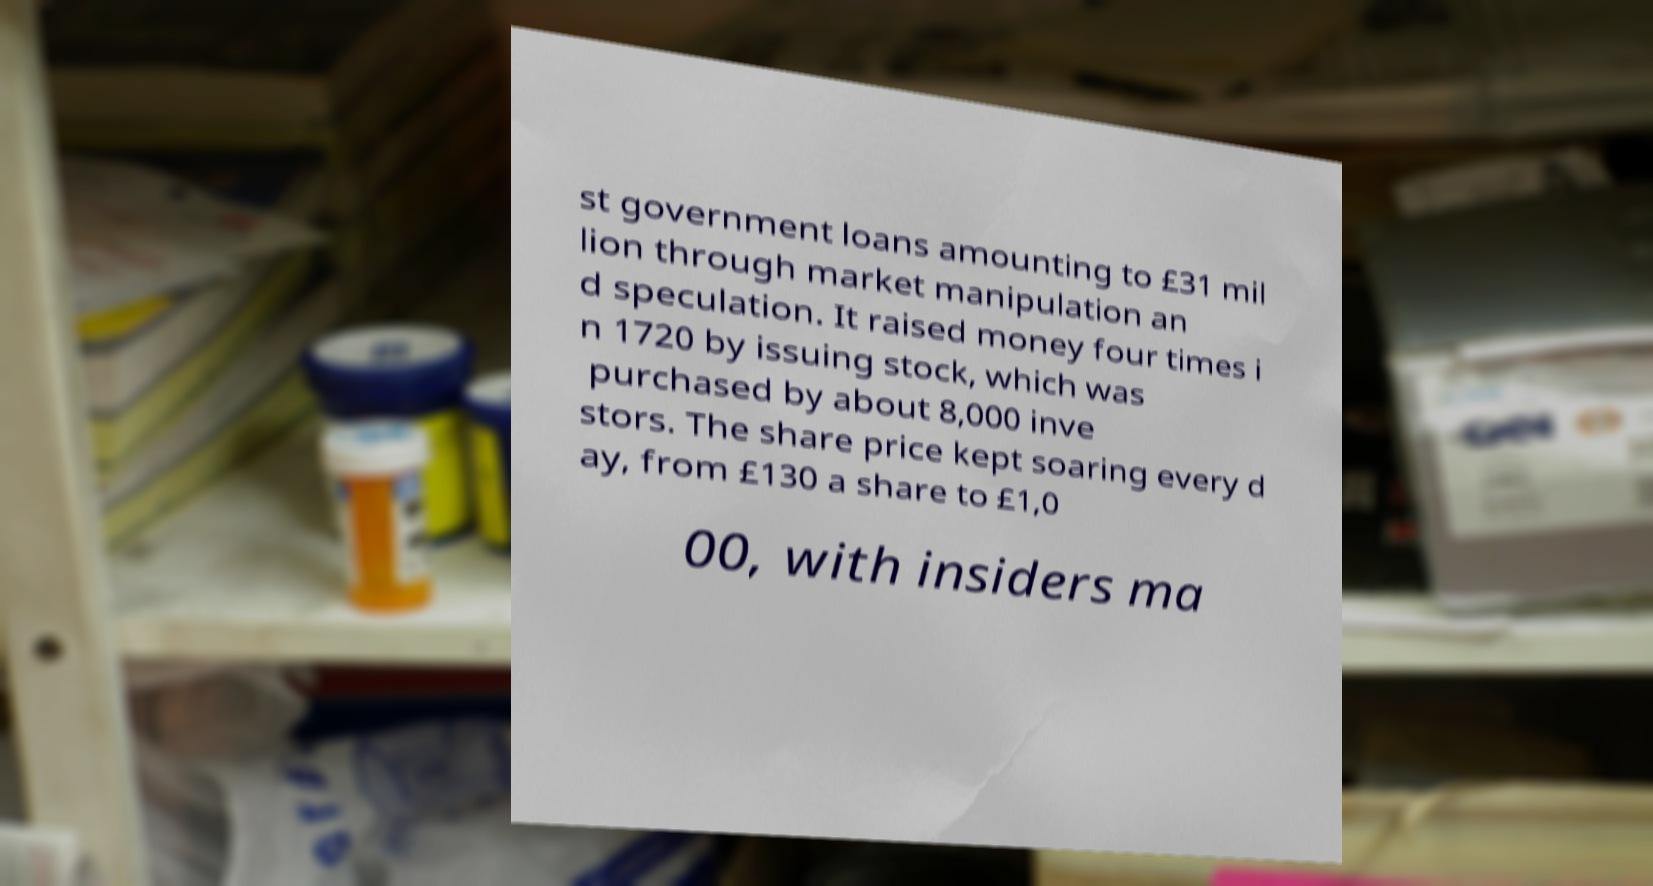For documentation purposes, I need the text within this image transcribed. Could you provide that? st government loans amounting to £31 mil lion through market manipulation an d speculation. It raised money four times i n 1720 by issuing stock, which was purchased by about 8,000 inve stors. The share price kept soaring every d ay, from £130 a share to £1,0 00, with insiders ma 